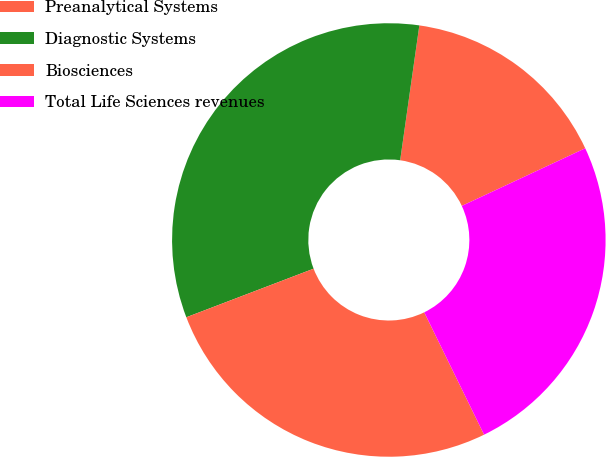Convert chart to OTSL. <chart><loc_0><loc_0><loc_500><loc_500><pie_chart><fcel>Preanalytical Systems<fcel>Diagnostic Systems<fcel>Biosciences<fcel>Total Life Sciences revenues<nl><fcel>15.8%<fcel>33.05%<fcel>26.44%<fcel>24.71%<nl></chart> 